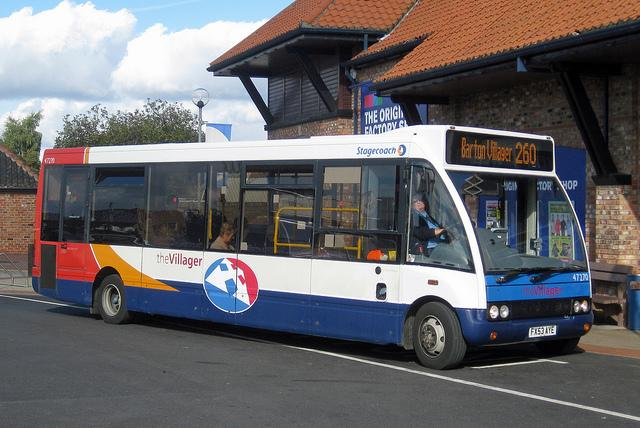Where does this bus stop here? barton villager 